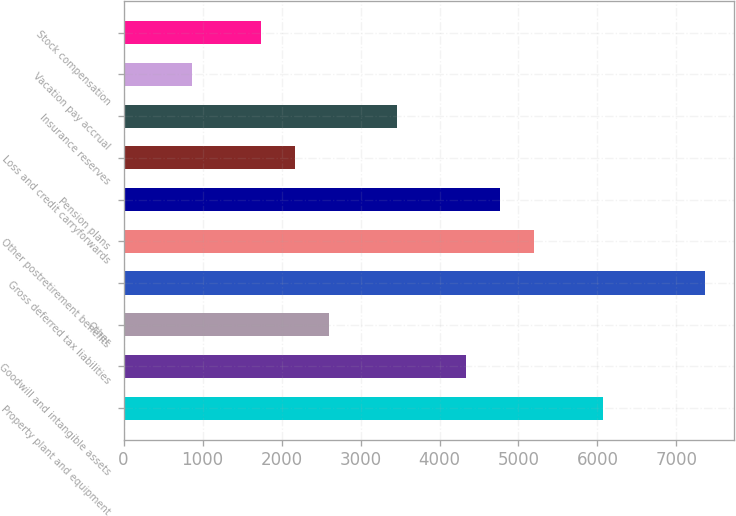Convert chart to OTSL. <chart><loc_0><loc_0><loc_500><loc_500><bar_chart><fcel>Property plant and equipment<fcel>Goodwill and intangible assets<fcel>Other<fcel>Gross deferred tax liabilities<fcel>Other postretirement benefits<fcel>Pension plans<fcel>Loss and credit carryforwards<fcel>Insurance reserves<fcel>Vacation pay accrual<fcel>Stock compensation<nl><fcel>6065.4<fcel>4333<fcel>2600.6<fcel>7364.7<fcel>5199.2<fcel>4766.1<fcel>2167.5<fcel>3466.8<fcel>868.2<fcel>1734.4<nl></chart> 